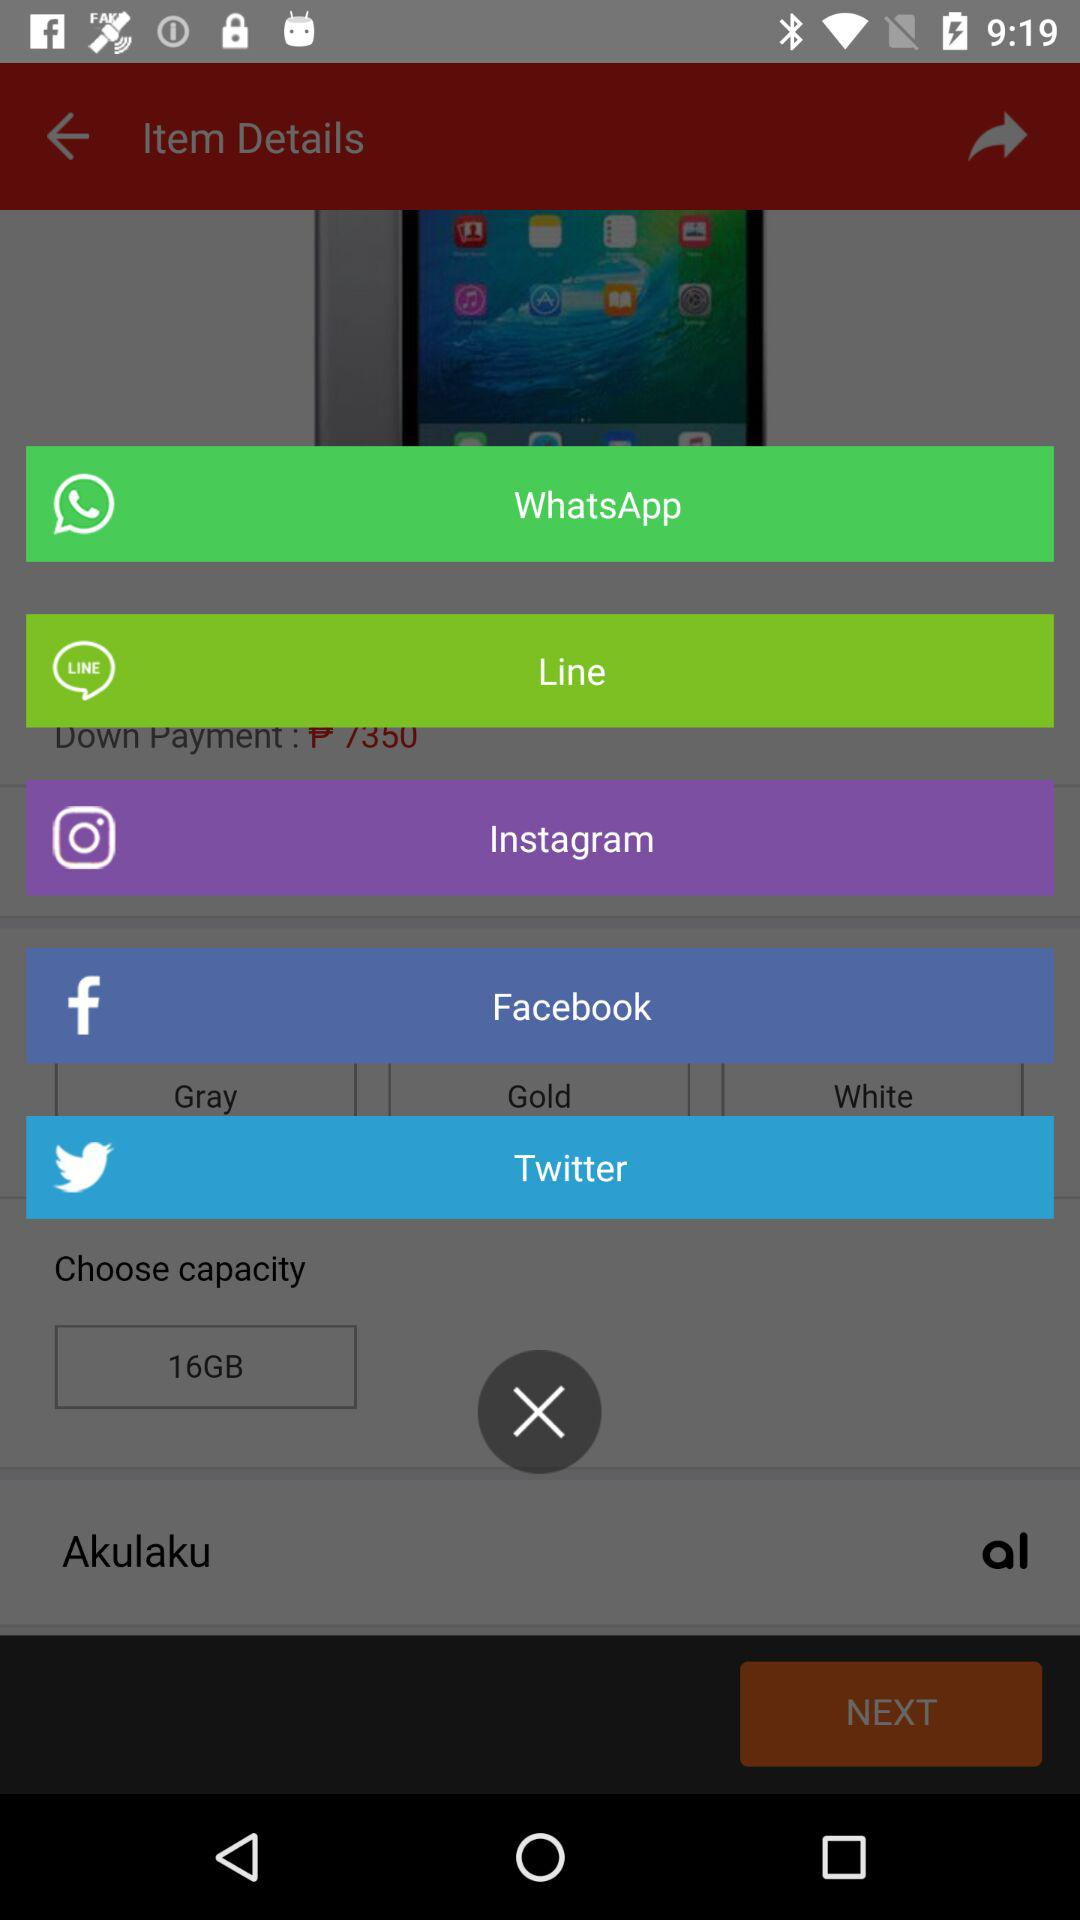How many color options are there for the phone?
Answer the question using a single word or phrase. 3 